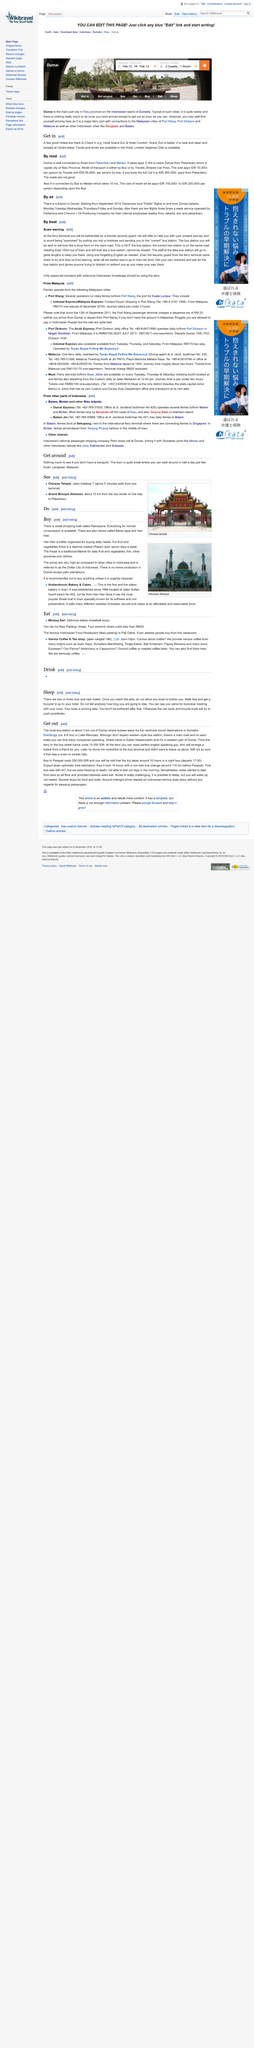Outline some significant characteristics in this image. The individual you will encounter at the ferry will be a skilled English speaker with impeccable communication abilities. The title for this section is 'Get out.' What should one not expect in Western style bus stations? 